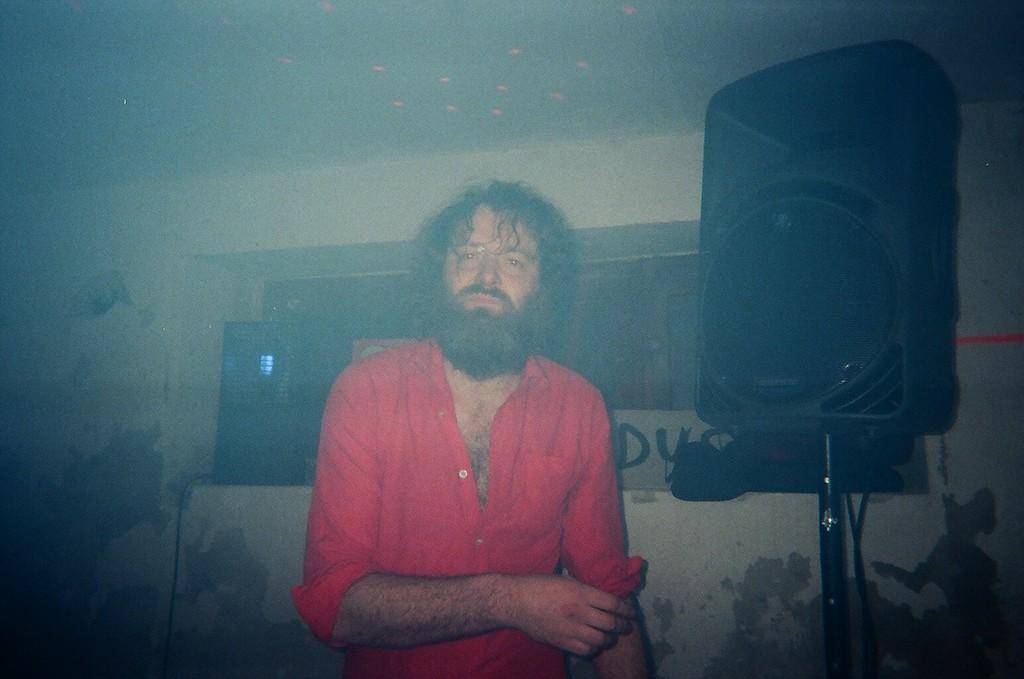Who is present in the image? There is a man in the image. What is the man wearing? The man is wearing a red shirt. What object is located beside the man? There is a speaker beside the man. What can be seen in the background of the image? There is a wall in the background of the image, and there are windows in the wall. What type of grape is the man holding in the image? There is no grape present in the image; the man is not holding anything. Is the man wearing a vest in the image? The provided facts do not mention a vest, only a red shirt. Can you see any deer in the image? There are no deer present in the image. 